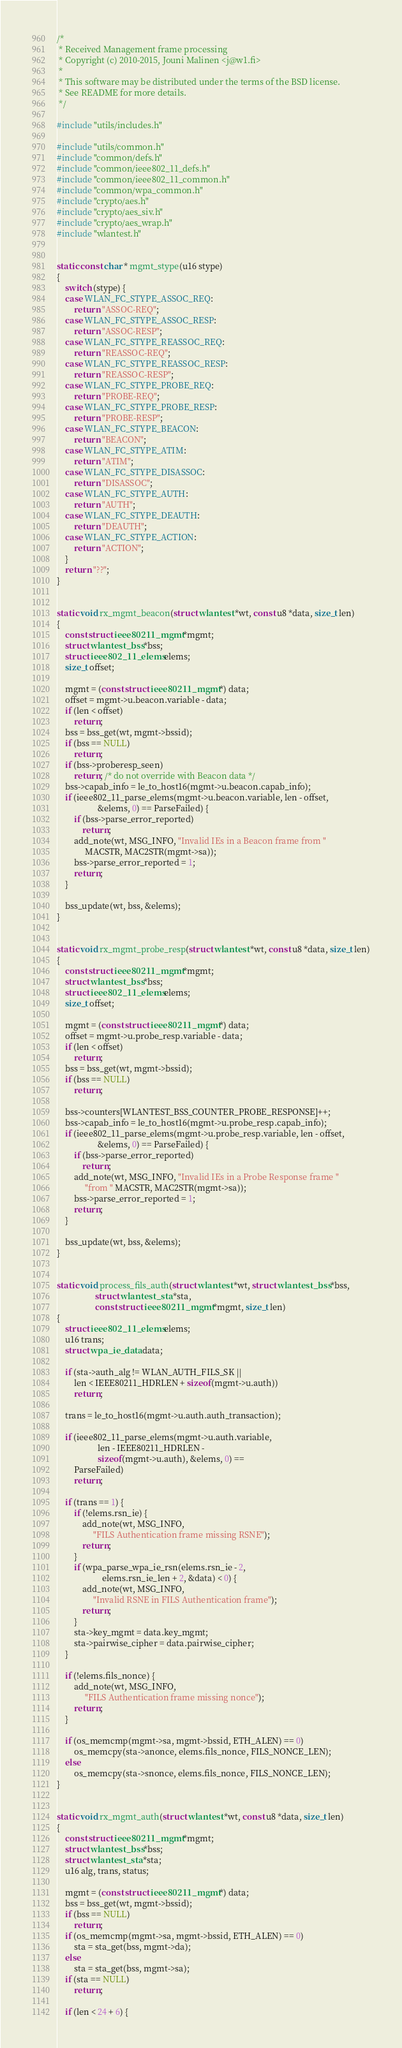Convert code to text. <code><loc_0><loc_0><loc_500><loc_500><_C_>/*
 * Received Management frame processing
 * Copyright (c) 2010-2015, Jouni Malinen <j@w1.fi>
 *
 * This software may be distributed under the terms of the BSD license.
 * See README for more details.
 */

#include "utils/includes.h"

#include "utils/common.h"
#include "common/defs.h"
#include "common/ieee802_11_defs.h"
#include "common/ieee802_11_common.h"
#include "common/wpa_common.h"
#include "crypto/aes.h"
#include "crypto/aes_siv.h"
#include "crypto/aes_wrap.h"
#include "wlantest.h"


static const char * mgmt_stype(u16 stype)
{
	switch (stype) {
	case WLAN_FC_STYPE_ASSOC_REQ:
		return "ASSOC-REQ";
	case WLAN_FC_STYPE_ASSOC_RESP:
		return "ASSOC-RESP";
	case WLAN_FC_STYPE_REASSOC_REQ:
		return "REASSOC-REQ";
	case WLAN_FC_STYPE_REASSOC_RESP:
		return "REASSOC-RESP";
	case WLAN_FC_STYPE_PROBE_REQ:
		return "PROBE-REQ";
	case WLAN_FC_STYPE_PROBE_RESP:
		return "PROBE-RESP";
	case WLAN_FC_STYPE_BEACON:
		return "BEACON";
	case WLAN_FC_STYPE_ATIM:
		return "ATIM";
	case WLAN_FC_STYPE_DISASSOC:
		return "DISASSOC";
	case WLAN_FC_STYPE_AUTH:
		return "AUTH";
	case WLAN_FC_STYPE_DEAUTH:
		return "DEAUTH";
	case WLAN_FC_STYPE_ACTION:
		return "ACTION";
	}
	return "??";
}


static void rx_mgmt_beacon(struct wlantest *wt, const u8 *data, size_t len)
{
	const struct ieee80211_mgmt *mgmt;
	struct wlantest_bss *bss;
	struct ieee802_11_elems elems;
	size_t offset;

	mgmt = (const struct ieee80211_mgmt *) data;
	offset = mgmt->u.beacon.variable - data;
	if (len < offset)
		return;
	bss = bss_get(wt, mgmt->bssid);
	if (bss == NULL)
		return;
	if (bss->proberesp_seen)
		return; /* do not override with Beacon data */
	bss->capab_info = le_to_host16(mgmt->u.beacon.capab_info);
	if (ieee802_11_parse_elems(mgmt->u.beacon.variable, len - offset,
				   &elems, 0) == ParseFailed) {
		if (bss->parse_error_reported)
			return;
		add_note(wt, MSG_INFO, "Invalid IEs in a Beacon frame from "
			 MACSTR, MAC2STR(mgmt->sa));
		bss->parse_error_reported = 1;
		return;
	}

	bss_update(wt, bss, &elems);
}


static void rx_mgmt_probe_resp(struct wlantest *wt, const u8 *data, size_t len)
{
	const struct ieee80211_mgmt *mgmt;
	struct wlantest_bss *bss;
	struct ieee802_11_elems elems;
	size_t offset;

	mgmt = (const struct ieee80211_mgmt *) data;
	offset = mgmt->u.probe_resp.variable - data;
	if (len < offset)
		return;
	bss = bss_get(wt, mgmt->bssid);
	if (bss == NULL)
		return;

	bss->counters[WLANTEST_BSS_COUNTER_PROBE_RESPONSE]++;
	bss->capab_info = le_to_host16(mgmt->u.probe_resp.capab_info);
	if (ieee802_11_parse_elems(mgmt->u.probe_resp.variable, len - offset,
				   &elems, 0) == ParseFailed) {
		if (bss->parse_error_reported)
			return;
		add_note(wt, MSG_INFO, "Invalid IEs in a Probe Response frame "
			 "from " MACSTR, MAC2STR(mgmt->sa));
		bss->parse_error_reported = 1;
		return;
	}

	bss_update(wt, bss, &elems);
}


static void process_fils_auth(struct wlantest *wt, struct wlantest_bss *bss,
			      struct wlantest_sta *sta,
			      const struct ieee80211_mgmt *mgmt, size_t len)
{
	struct ieee802_11_elems elems;
	u16 trans;
	struct wpa_ie_data data;

	if (sta->auth_alg != WLAN_AUTH_FILS_SK ||
	    len < IEEE80211_HDRLEN + sizeof(mgmt->u.auth))
		return;

	trans = le_to_host16(mgmt->u.auth.auth_transaction);

	if (ieee802_11_parse_elems(mgmt->u.auth.variable,
				   len - IEEE80211_HDRLEN -
				   sizeof(mgmt->u.auth), &elems, 0) ==
	    ParseFailed)
		return;

	if (trans == 1) {
		if (!elems.rsn_ie) {
			add_note(wt, MSG_INFO,
				 "FILS Authentication frame missing RSNE");
			return;
		}
		if (wpa_parse_wpa_ie_rsn(elems.rsn_ie - 2,
					 elems.rsn_ie_len + 2, &data) < 0) {
			add_note(wt, MSG_INFO,
				 "Invalid RSNE in FILS Authentication frame");
			return;
		}
		sta->key_mgmt = data.key_mgmt;
		sta->pairwise_cipher = data.pairwise_cipher;
	}

	if (!elems.fils_nonce) {
		add_note(wt, MSG_INFO,
			 "FILS Authentication frame missing nonce");
		return;
	}

	if (os_memcmp(mgmt->sa, mgmt->bssid, ETH_ALEN) == 0)
		os_memcpy(sta->anonce, elems.fils_nonce, FILS_NONCE_LEN);
	else
		os_memcpy(sta->snonce, elems.fils_nonce, FILS_NONCE_LEN);
}


static void rx_mgmt_auth(struct wlantest *wt, const u8 *data, size_t len)
{
	const struct ieee80211_mgmt *mgmt;
	struct wlantest_bss *bss;
	struct wlantest_sta *sta;
	u16 alg, trans, status;

	mgmt = (const struct ieee80211_mgmt *) data;
	bss = bss_get(wt, mgmt->bssid);
	if (bss == NULL)
		return;
	if (os_memcmp(mgmt->sa, mgmt->bssid, ETH_ALEN) == 0)
		sta = sta_get(bss, mgmt->da);
	else
		sta = sta_get(bss, mgmt->sa);
	if (sta == NULL)
		return;

	if (len < 24 + 6) {</code> 